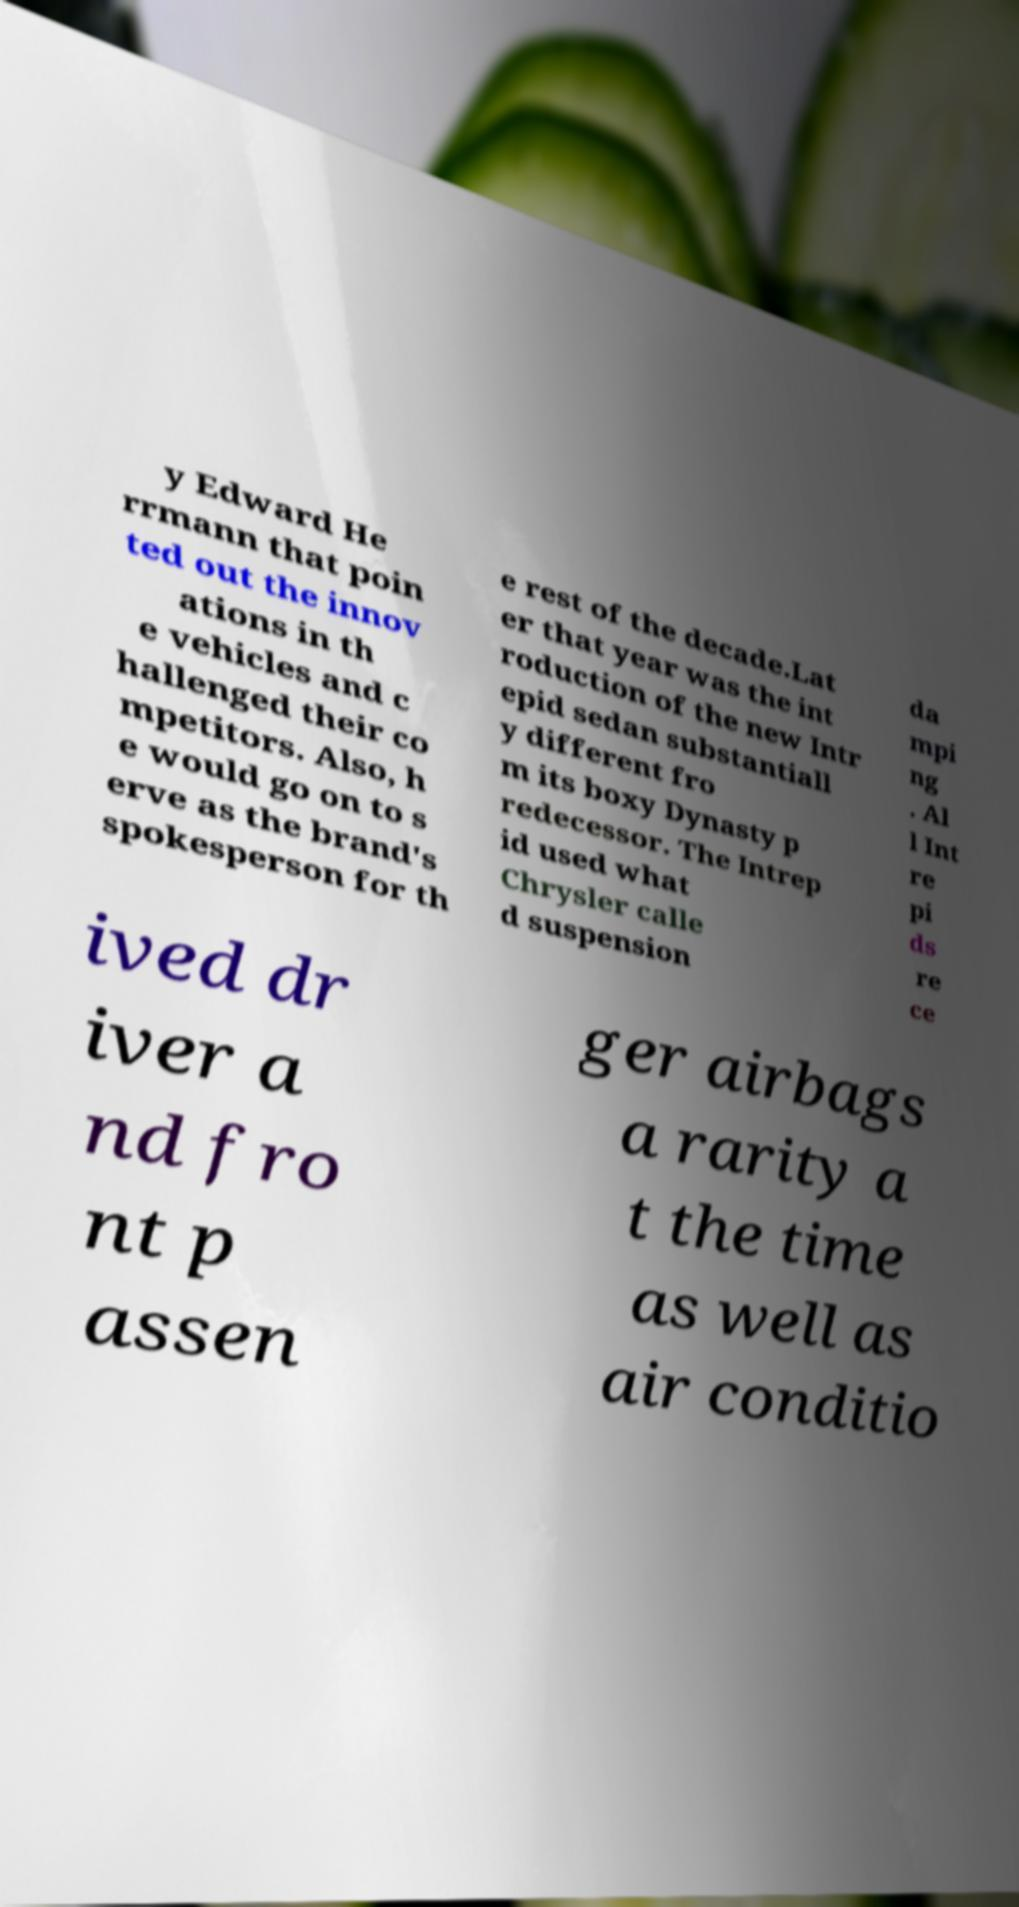Can you accurately transcribe the text from the provided image for me? y Edward He rrmann that poin ted out the innov ations in th e vehicles and c hallenged their co mpetitors. Also, h e would go on to s erve as the brand's spokesperson for th e rest of the decade.Lat er that year was the int roduction of the new Intr epid sedan substantiall y different fro m its boxy Dynasty p redecessor. The Intrep id used what Chrysler calle d suspension da mpi ng . Al l Int re pi ds re ce ived dr iver a nd fro nt p assen ger airbags a rarity a t the time as well as air conditio 